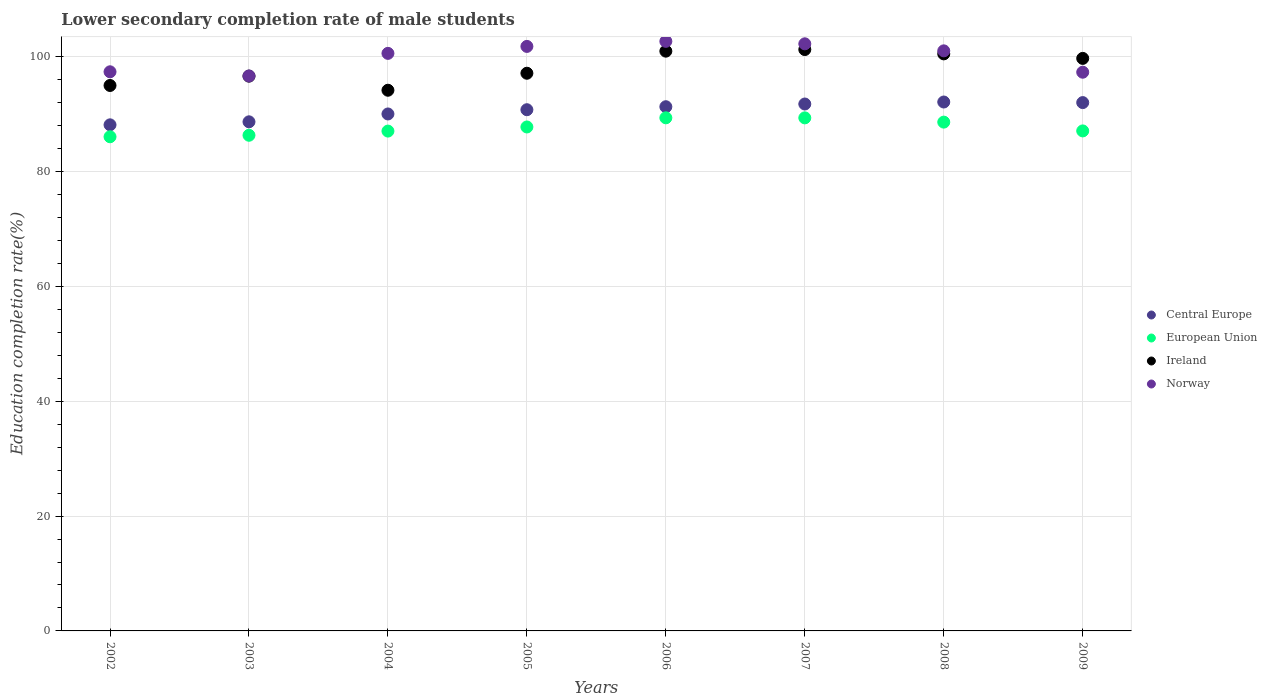How many different coloured dotlines are there?
Make the answer very short. 4. Is the number of dotlines equal to the number of legend labels?
Ensure brevity in your answer.  Yes. What is the lower secondary completion rate of male students in European Union in 2009?
Ensure brevity in your answer.  87.06. Across all years, what is the maximum lower secondary completion rate of male students in Norway?
Your answer should be very brief. 102.66. Across all years, what is the minimum lower secondary completion rate of male students in Ireland?
Make the answer very short. 94.14. What is the total lower secondary completion rate of male students in Ireland in the graph?
Provide a succinct answer. 785.17. What is the difference between the lower secondary completion rate of male students in Ireland in 2003 and that in 2008?
Keep it short and to the point. -3.88. What is the difference between the lower secondary completion rate of male students in European Union in 2003 and the lower secondary completion rate of male students in Central Europe in 2009?
Offer a very short reply. -5.69. What is the average lower secondary completion rate of male students in Norway per year?
Ensure brevity in your answer.  99.94. In the year 2003, what is the difference between the lower secondary completion rate of male students in Central Europe and lower secondary completion rate of male students in Norway?
Provide a succinct answer. -7.98. In how many years, is the lower secondary completion rate of male students in Norway greater than 8 %?
Keep it short and to the point. 8. What is the ratio of the lower secondary completion rate of male students in Norway in 2002 to that in 2007?
Offer a very short reply. 0.95. What is the difference between the highest and the second highest lower secondary completion rate of male students in Norway?
Provide a short and direct response. 0.43. What is the difference between the highest and the lowest lower secondary completion rate of male students in European Union?
Offer a terse response. 3.3. In how many years, is the lower secondary completion rate of male students in European Union greater than the average lower secondary completion rate of male students in European Union taken over all years?
Your response must be concise. 4. Is it the case that in every year, the sum of the lower secondary completion rate of male students in Norway and lower secondary completion rate of male students in Central Europe  is greater than the lower secondary completion rate of male students in Ireland?
Give a very brief answer. Yes. Does the lower secondary completion rate of male students in Ireland monotonically increase over the years?
Provide a short and direct response. No. Is the lower secondary completion rate of male students in Ireland strictly greater than the lower secondary completion rate of male students in Norway over the years?
Offer a very short reply. No. Is the lower secondary completion rate of male students in Ireland strictly less than the lower secondary completion rate of male students in Norway over the years?
Your answer should be very brief. No. How many dotlines are there?
Your answer should be very brief. 4. Does the graph contain grids?
Your response must be concise. Yes. How many legend labels are there?
Your answer should be very brief. 4. What is the title of the graph?
Offer a terse response. Lower secondary completion rate of male students. What is the label or title of the X-axis?
Make the answer very short. Years. What is the label or title of the Y-axis?
Make the answer very short. Education completion rate(%). What is the Education completion rate(%) in Central Europe in 2002?
Provide a succinct answer. 88.12. What is the Education completion rate(%) in European Union in 2002?
Give a very brief answer. 86.04. What is the Education completion rate(%) of Ireland in 2002?
Your answer should be very brief. 94.97. What is the Education completion rate(%) of Norway in 2002?
Offer a terse response. 97.36. What is the Education completion rate(%) of Central Europe in 2003?
Make the answer very short. 88.65. What is the Education completion rate(%) in European Union in 2003?
Offer a very short reply. 86.31. What is the Education completion rate(%) of Ireland in 2003?
Your response must be concise. 96.6. What is the Education completion rate(%) in Norway in 2003?
Give a very brief answer. 96.63. What is the Education completion rate(%) in Central Europe in 2004?
Your response must be concise. 90.01. What is the Education completion rate(%) in European Union in 2004?
Ensure brevity in your answer.  87.03. What is the Education completion rate(%) in Ireland in 2004?
Offer a terse response. 94.14. What is the Education completion rate(%) in Norway in 2004?
Your answer should be compact. 100.57. What is the Education completion rate(%) of Central Europe in 2005?
Your answer should be very brief. 90.75. What is the Education completion rate(%) of European Union in 2005?
Ensure brevity in your answer.  87.75. What is the Education completion rate(%) of Ireland in 2005?
Provide a succinct answer. 97.1. What is the Education completion rate(%) of Norway in 2005?
Keep it short and to the point. 101.78. What is the Education completion rate(%) of Central Europe in 2006?
Your answer should be compact. 91.27. What is the Education completion rate(%) of European Union in 2006?
Your response must be concise. 89.34. What is the Education completion rate(%) in Ireland in 2006?
Provide a succinct answer. 100.95. What is the Education completion rate(%) of Norway in 2006?
Ensure brevity in your answer.  102.66. What is the Education completion rate(%) of Central Europe in 2007?
Keep it short and to the point. 91.75. What is the Education completion rate(%) in European Union in 2007?
Your response must be concise. 89.34. What is the Education completion rate(%) in Ireland in 2007?
Ensure brevity in your answer.  101.23. What is the Education completion rate(%) in Norway in 2007?
Your response must be concise. 102.23. What is the Education completion rate(%) in Central Europe in 2008?
Provide a short and direct response. 92.1. What is the Education completion rate(%) in European Union in 2008?
Provide a short and direct response. 88.59. What is the Education completion rate(%) of Ireland in 2008?
Keep it short and to the point. 100.48. What is the Education completion rate(%) in Norway in 2008?
Your answer should be compact. 101. What is the Education completion rate(%) of Central Europe in 2009?
Your response must be concise. 91.99. What is the Education completion rate(%) in European Union in 2009?
Give a very brief answer. 87.06. What is the Education completion rate(%) of Ireland in 2009?
Ensure brevity in your answer.  99.69. What is the Education completion rate(%) of Norway in 2009?
Your answer should be compact. 97.28. Across all years, what is the maximum Education completion rate(%) in Central Europe?
Offer a very short reply. 92.1. Across all years, what is the maximum Education completion rate(%) in European Union?
Offer a terse response. 89.34. Across all years, what is the maximum Education completion rate(%) in Ireland?
Offer a terse response. 101.23. Across all years, what is the maximum Education completion rate(%) of Norway?
Ensure brevity in your answer.  102.66. Across all years, what is the minimum Education completion rate(%) in Central Europe?
Offer a terse response. 88.12. Across all years, what is the minimum Education completion rate(%) of European Union?
Give a very brief answer. 86.04. Across all years, what is the minimum Education completion rate(%) in Ireland?
Make the answer very short. 94.14. Across all years, what is the minimum Education completion rate(%) in Norway?
Offer a very short reply. 96.63. What is the total Education completion rate(%) of Central Europe in the graph?
Your answer should be compact. 724.64. What is the total Education completion rate(%) in European Union in the graph?
Offer a terse response. 701.47. What is the total Education completion rate(%) of Ireland in the graph?
Your answer should be very brief. 785.17. What is the total Education completion rate(%) of Norway in the graph?
Your answer should be very brief. 799.5. What is the difference between the Education completion rate(%) of Central Europe in 2002 and that in 2003?
Your response must be concise. -0.53. What is the difference between the Education completion rate(%) of European Union in 2002 and that in 2003?
Ensure brevity in your answer.  -0.26. What is the difference between the Education completion rate(%) of Ireland in 2002 and that in 2003?
Make the answer very short. -1.63. What is the difference between the Education completion rate(%) of Norway in 2002 and that in 2003?
Give a very brief answer. 0.73. What is the difference between the Education completion rate(%) in Central Europe in 2002 and that in 2004?
Offer a terse response. -1.89. What is the difference between the Education completion rate(%) in European Union in 2002 and that in 2004?
Your answer should be compact. -0.99. What is the difference between the Education completion rate(%) in Ireland in 2002 and that in 2004?
Ensure brevity in your answer.  0.83. What is the difference between the Education completion rate(%) in Norway in 2002 and that in 2004?
Offer a very short reply. -3.21. What is the difference between the Education completion rate(%) in Central Europe in 2002 and that in 2005?
Offer a very short reply. -2.63. What is the difference between the Education completion rate(%) of European Union in 2002 and that in 2005?
Keep it short and to the point. -1.7. What is the difference between the Education completion rate(%) of Ireland in 2002 and that in 2005?
Keep it short and to the point. -2.13. What is the difference between the Education completion rate(%) in Norway in 2002 and that in 2005?
Your response must be concise. -4.42. What is the difference between the Education completion rate(%) in Central Europe in 2002 and that in 2006?
Make the answer very short. -3.15. What is the difference between the Education completion rate(%) in European Union in 2002 and that in 2006?
Keep it short and to the point. -3.3. What is the difference between the Education completion rate(%) of Ireland in 2002 and that in 2006?
Offer a terse response. -5.98. What is the difference between the Education completion rate(%) in Norway in 2002 and that in 2006?
Make the answer very short. -5.3. What is the difference between the Education completion rate(%) of Central Europe in 2002 and that in 2007?
Your answer should be compact. -3.63. What is the difference between the Education completion rate(%) of European Union in 2002 and that in 2007?
Offer a terse response. -3.29. What is the difference between the Education completion rate(%) in Ireland in 2002 and that in 2007?
Ensure brevity in your answer.  -6.26. What is the difference between the Education completion rate(%) of Norway in 2002 and that in 2007?
Make the answer very short. -4.87. What is the difference between the Education completion rate(%) of Central Europe in 2002 and that in 2008?
Your response must be concise. -3.97. What is the difference between the Education completion rate(%) of European Union in 2002 and that in 2008?
Ensure brevity in your answer.  -2.55. What is the difference between the Education completion rate(%) of Ireland in 2002 and that in 2008?
Your response must be concise. -5.5. What is the difference between the Education completion rate(%) in Norway in 2002 and that in 2008?
Your response must be concise. -3.65. What is the difference between the Education completion rate(%) in Central Europe in 2002 and that in 2009?
Provide a short and direct response. -3.87. What is the difference between the Education completion rate(%) of European Union in 2002 and that in 2009?
Make the answer very short. -1.02. What is the difference between the Education completion rate(%) of Ireland in 2002 and that in 2009?
Keep it short and to the point. -4.72. What is the difference between the Education completion rate(%) in Norway in 2002 and that in 2009?
Offer a very short reply. 0.07. What is the difference between the Education completion rate(%) in Central Europe in 2003 and that in 2004?
Provide a succinct answer. -1.37. What is the difference between the Education completion rate(%) in European Union in 2003 and that in 2004?
Make the answer very short. -0.73. What is the difference between the Education completion rate(%) in Ireland in 2003 and that in 2004?
Provide a succinct answer. 2.46. What is the difference between the Education completion rate(%) in Norway in 2003 and that in 2004?
Your answer should be compact. -3.93. What is the difference between the Education completion rate(%) of Central Europe in 2003 and that in 2005?
Ensure brevity in your answer.  -2.11. What is the difference between the Education completion rate(%) of European Union in 2003 and that in 2005?
Your answer should be compact. -1.44. What is the difference between the Education completion rate(%) in Ireland in 2003 and that in 2005?
Offer a terse response. -0.5. What is the difference between the Education completion rate(%) of Norway in 2003 and that in 2005?
Give a very brief answer. -5.14. What is the difference between the Education completion rate(%) of Central Europe in 2003 and that in 2006?
Your answer should be very brief. -2.63. What is the difference between the Education completion rate(%) in European Union in 2003 and that in 2006?
Offer a very short reply. -3.04. What is the difference between the Education completion rate(%) in Ireland in 2003 and that in 2006?
Ensure brevity in your answer.  -4.35. What is the difference between the Education completion rate(%) of Norway in 2003 and that in 2006?
Make the answer very short. -6.03. What is the difference between the Education completion rate(%) in Central Europe in 2003 and that in 2007?
Provide a succinct answer. -3.1. What is the difference between the Education completion rate(%) in European Union in 2003 and that in 2007?
Give a very brief answer. -3.03. What is the difference between the Education completion rate(%) of Ireland in 2003 and that in 2007?
Offer a terse response. -4.63. What is the difference between the Education completion rate(%) of Norway in 2003 and that in 2007?
Provide a short and direct response. -5.6. What is the difference between the Education completion rate(%) in Central Europe in 2003 and that in 2008?
Offer a very short reply. -3.45. What is the difference between the Education completion rate(%) in European Union in 2003 and that in 2008?
Provide a succinct answer. -2.29. What is the difference between the Education completion rate(%) of Ireland in 2003 and that in 2008?
Offer a terse response. -3.88. What is the difference between the Education completion rate(%) in Norway in 2003 and that in 2008?
Your response must be concise. -4.37. What is the difference between the Education completion rate(%) in Central Europe in 2003 and that in 2009?
Give a very brief answer. -3.35. What is the difference between the Education completion rate(%) in European Union in 2003 and that in 2009?
Provide a succinct answer. -0.76. What is the difference between the Education completion rate(%) of Ireland in 2003 and that in 2009?
Provide a short and direct response. -3.09. What is the difference between the Education completion rate(%) in Norway in 2003 and that in 2009?
Offer a very short reply. -0.65. What is the difference between the Education completion rate(%) of Central Europe in 2004 and that in 2005?
Offer a very short reply. -0.74. What is the difference between the Education completion rate(%) in European Union in 2004 and that in 2005?
Keep it short and to the point. -0.72. What is the difference between the Education completion rate(%) in Ireland in 2004 and that in 2005?
Keep it short and to the point. -2.96. What is the difference between the Education completion rate(%) in Norway in 2004 and that in 2005?
Give a very brief answer. -1.21. What is the difference between the Education completion rate(%) in Central Europe in 2004 and that in 2006?
Ensure brevity in your answer.  -1.26. What is the difference between the Education completion rate(%) in European Union in 2004 and that in 2006?
Your response must be concise. -2.31. What is the difference between the Education completion rate(%) of Ireland in 2004 and that in 2006?
Your answer should be compact. -6.81. What is the difference between the Education completion rate(%) in Norway in 2004 and that in 2006?
Offer a very short reply. -2.09. What is the difference between the Education completion rate(%) in Central Europe in 2004 and that in 2007?
Provide a short and direct response. -1.73. What is the difference between the Education completion rate(%) in European Union in 2004 and that in 2007?
Offer a very short reply. -2.3. What is the difference between the Education completion rate(%) of Ireland in 2004 and that in 2007?
Your answer should be compact. -7.09. What is the difference between the Education completion rate(%) in Norway in 2004 and that in 2007?
Give a very brief answer. -1.66. What is the difference between the Education completion rate(%) in Central Europe in 2004 and that in 2008?
Provide a succinct answer. -2.08. What is the difference between the Education completion rate(%) in European Union in 2004 and that in 2008?
Ensure brevity in your answer.  -1.56. What is the difference between the Education completion rate(%) of Ireland in 2004 and that in 2008?
Your answer should be very brief. -6.33. What is the difference between the Education completion rate(%) of Norway in 2004 and that in 2008?
Your answer should be compact. -0.44. What is the difference between the Education completion rate(%) in Central Europe in 2004 and that in 2009?
Provide a succinct answer. -1.98. What is the difference between the Education completion rate(%) in European Union in 2004 and that in 2009?
Give a very brief answer. -0.03. What is the difference between the Education completion rate(%) in Ireland in 2004 and that in 2009?
Provide a short and direct response. -5.54. What is the difference between the Education completion rate(%) of Norway in 2004 and that in 2009?
Your response must be concise. 3.28. What is the difference between the Education completion rate(%) in Central Europe in 2005 and that in 2006?
Give a very brief answer. -0.52. What is the difference between the Education completion rate(%) in European Union in 2005 and that in 2006?
Make the answer very short. -1.59. What is the difference between the Education completion rate(%) in Ireland in 2005 and that in 2006?
Provide a succinct answer. -3.85. What is the difference between the Education completion rate(%) of Norway in 2005 and that in 2006?
Make the answer very short. -0.88. What is the difference between the Education completion rate(%) in Central Europe in 2005 and that in 2007?
Give a very brief answer. -0.99. What is the difference between the Education completion rate(%) of European Union in 2005 and that in 2007?
Provide a succinct answer. -1.59. What is the difference between the Education completion rate(%) of Ireland in 2005 and that in 2007?
Offer a terse response. -4.12. What is the difference between the Education completion rate(%) of Norway in 2005 and that in 2007?
Provide a short and direct response. -0.45. What is the difference between the Education completion rate(%) in Central Europe in 2005 and that in 2008?
Provide a succinct answer. -1.34. What is the difference between the Education completion rate(%) of European Union in 2005 and that in 2008?
Ensure brevity in your answer.  -0.84. What is the difference between the Education completion rate(%) in Ireland in 2005 and that in 2008?
Provide a short and direct response. -3.37. What is the difference between the Education completion rate(%) of Norway in 2005 and that in 2008?
Ensure brevity in your answer.  0.77. What is the difference between the Education completion rate(%) of Central Europe in 2005 and that in 2009?
Keep it short and to the point. -1.24. What is the difference between the Education completion rate(%) of European Union in 2005 and that in 2009?
Offer a very short reply. 0.69. What is the difference between the Education completion rate(%) in Ireland in 2005 and that in 2009?
Make the answer very short. -2.58. What is the difference between the Education completion rate(%) in Norway in 2005 and that in 2009?
Your answer should be very brief. 4.49. What is the difference between the Education completion rate(%) in Central Europe in 2006 and that in 2007?
Your response must be concise. -0.47. What is the difference between the Education completion rate(%) in European Union in 2006 and that in 2007?
Your response must be concise. 0.01. What is the difference between the Education completion rate(%) in Ireland in 2006 and that in 2007?
Keep it short and to the point. -0.28. What is the difference between the Education completion rate(%) in Norway in 2006 and that in 2007?
Provide a succinct answer. 0.43. What is the difference between the Education completion rate(%) of Central Europe in 2006 and that in 2008?
Give a very brief answer. -0.82. What is the difference between the Education completion rate(%) in European Union in 2006 and that in 2008?
Make the answer very short. 0.75. What is the difference between the Education completion rate(%) in Ireland in 2006 and that in 2008?
Keep it short and to the point. 0.47. What is the difference between the Education completion rate(%) of Norway in 2006 and that in 2008?
Provide a succinct answer. 1.65. What is the difference between the Education completion rate(%) in Central Europe in 2006 and that in 2009?
Offer a very short reply. -0.72. What is the difference between the Education completion rate(%) in European Union in 2006 and that in 2009?
Give a very brief answer. 2.28. What is the difference between the Education completion rate(%) in Ireland in 2006 and that in 2009?
Your response must be concise. 1.26. What is the difference between the Education completion rate(%) in Norway in 2006 and that in 2009?
Give a very brief answer. 5.38. What is the difference between the Education completion rate(%) in Central Europe in 2007 and that in 2008?
Provide a succinct answer. -0.35. What is the difference between the Education completion rate(%) of European Union in 2007 and that in 2008?
Offer a very short reply. 0.74. What is the difference between the Education completion rate(%) in Ireland in 2007 and that in 2008?
Give a very brief answer. 0.75. What is the difference between the Education completion rate(%) of Norway in 2007 and that in 2008?
Offer a very short reply. 1.22. What is the difference between the Education completion rate(%) in Central Europe in 2007 and that in 2009?
Ensure brevity in your answer.  -0.25. What is the difference between the Education completion rate(%) of European Union in 2007 and that in 2009?
Offer a very short reply. 2.27. What is the difference between the Education completion rate(%) of Ireland in 2007 and that in 2009?
Keep it short and to the point. 1.54. What is the difference between the Education completion rate(%) of Norway in 2007 and that in 2009?
Provide a succinct answer. 4.94. What is the difference between the Education completion rate(%) of Central Europe in 2008 and that in 2009?
Make the answer very short. 0.1. What is the difference between the Education completion rate(%) of European Union in 2008 and that in 2009?
Your answer should be compact. 1.53. What is the difference between the Education completion rate(%) of Ireland in 2008 and that in 2009?
Give a very brief answer. 0.79. What is the difference between the Education completion rate(%) of Norway in 2008 and that in 2009?
Offer a very short reply. 3.72. What is the difference between the Education completion rate(%) in Central Europe in 2002 and the Education completion rate(%) in European Union in 2003?
Your response must be concise. 1.82. What is the difference between the Education completion rate(%) in Central Europe in 2002 and the Education completion rate(%) in Ireland in 2003?
Provide a short and direct response. -8.48. What is the difference between the Education completion rate(%) in Central Europe in 2002 and the Education completion rate(%) in Norway in 2003?
Your response must be concise. -8.51. What is the difference between the Education completion rate(%) of European Union in 2002 and the Education completion rate(%) of Ireland in 2003?
Your response must be concise. -10.56. What is the difference between the Education completion rate(%) of European Union in 2002 and the Education completion rate(%) of Norway in 2003?
Keep it short and to the point. -10.59. What is the difference between the Education completion rate(%) of Ireland in 2002 and the Education completion rate(%) of Norway in 2003?
Offer a very short reply. -1.66. What is the difference between the Education completion rate(%) of Central Europe in 2002 and the Education completion rate(%) of European Union in 2004?
Keep it short and to the point. 1.09. What is the difference between the Education completion rate(%) in Central Europe in 2002 and the Education completion rate(%) in Ireland in 2004?
Ensure brevity in your answer.  -6.02. What is the difference between the Education completion rate(%) in Central Europe in 2002 and the Education completion rate(%) in Norway in 2004?
Your response must be concise. -12.44. What is the difference between the Education completion rate(%) of European Union in 2002 and the Education completion rate(%) of Ireland in 2004?
Your response must be concise. -8.1. What is the difference between the Education completion rate(%) of European Union in 2002 and the Education completion rate(%) of Norway in 2004?
Offer a very short reply. -14.52. What is the difference between the Education completion rate(%) of Ireland in 2002 and the Education completion rate(%) of Norway in 2004?
Provide a short and direct response. -5.59. What is the difference between the Education completion rate(%) in Central Europe in 2002 and the Education completion rate(%) in European Union in 2005?
Your answer should be very brief. 0.37. What is the difference between the Education completion rate(%) of Central Europe in 2002 and the Education completion rate(%) of Ireland in 2005?
Make the answer very short. -8.98. What is the difference between the Education completion rate(%) in Central Europe in 2002 and the Education completion rate(%) in Norway in 2005?
Provide a short and direct response. -13.66. What is the difference between the Education completion rate(%) of European Union in 2002 and the Education completion rate(%) of Ireland in 2005?
Give a very brief answer. -11.06. What is the difference between the Education completion rate(%) of European Union in 2002 and the Education completion rate(%) of Norway in 2005?
Your response must be concise. -15.73. What is the difference between the Education completion rate(%) of Ireland in 2002 and the Education completion rate(%) of Norway in 2005?
Provide a succinct answer. -6.8. What is the difference between the Education completion rate(%) of Central Europe in 2002 and the Education completion rate(%) of European Union in 2006?
Ensure brevity in your answer.  -1.22. What is the difference between the Education completion rate(%) of Central Europe in 2002 and the Education completion rate(%) of Ireland in 2006?
Provide a short and direct response. -12.83. What is the difference between the Education completion rate(%) in Central Europe in 2002 and the Education completion rate(%) in Norway in 2006?
Give a very brief answer. -14.54. What is the difference between the Education completion rate(%) of European Union in 2002 and the Education completion rate(%) of Ireland in 2006?
Make the answer very short. -14.9. What is the difference between the Education completion rate(%) of European Union in 2002 and the Education completion rate(%) of Norway in 2006?
Keep it short and to the point. -16.61. What is the difference between the Education completion rate(%) in Ireland in 2002 and the Education completion rate(%) in Norway in 2006?
Your answer should be very brief. -7.69. What is the difference between the Education completion rate(%) of Central Europe in 2002 and the Education completion rate(%) of European Union in 2007?
Provide a succinct answer. -1.21. What is the difference between the Education completion rate(%) of Central Europe in 2002 and the Education completion rate(%) of Ireland in 2007?
Your answer should be very brief. -13.11. What is the difference between the Education completion rate(%) in Central Europe in 2002 and the Education completion rate(%) in Norway in 2007?
Offer a very short reply. -14.11. What is the difference between the Education completion rate(%) of European Union in 2002 and the Education completion rate(%) of Ireland in 2007?
Provide a succinct answer. -15.18. What is the difference between the Education completion rate(%) of European Union in 2002 and the Education completion rate(%) of Norway in 2007?
Your answer should be very brief. -16.18. What is the difference between the Education completion rate(%) of Ireland in 2002 and the Education completion rate(%) of Norway in 2007?
Provide a succinct answer. -7.25. What is the difference between the Education completion rate(%) in Central Europe in 2002 and the Education completion rate(%) in European Union in 2008?
Keep it short and to the point. -0.47. What is the difference between the Education completion rate(%) of Central Europe in 2002 and the Education completion rate(%) of Ireland in 2008?
Your answer should be very brief. -12.36. What is the difference between the Education completion rate(%) of Central Europe in 2002 and the Education completion rate(%) of Norway in 2008?
Ensure brevity in your answer.  -12.88. What is the difference between the Education completion rate(%) of European Union in 2002 and the Education completion rate(%) of Ireland in 2008?
Make the answer very short. -14.43. What is the difference between the Education completion rate(%) in European Union in 2002 and the Education completion rate(%) in Norway in 2008?
Your response must be concise. -14.96. What is the difference between the Education completion rate(%) in Ireland in 2002 and the Education completion rate(%) in Norway in 2008?
Give a very brief answer. -6.03. What is the difference between the Education completion rate(%) in Central Europe in 2002 and the Education completion rate(%) in European Union in 2009?
Offer a very short reply. 1.06. What is the difference between the Education completion rate(%) of Central Europe in 2002 and the Education completion rate(%) of Ireland in 2009?
Provide a succinct answer. -11.57. What is the difference between the Education completion rate(%) in Central Europe in 2002 and the Education completion rate(%) in Norway in 2009?
Keep it short and to the point. -9.16. What is the difference between the Education completion rate(%) of European Union in 2002 and the Education completion rate(%) of Ireland in 2009?
Provide a succinct answer. -13.64. What is the difference between the Education completion rate(%) in European Union in 2002 and the Education completion rate(%) in Norway in 2009?
Offer a very short reply. -11.24. What is the difference between the Education completion rate(%) in Ireland in 2002 and the Education completion rate(%) in Norway in 2009?
Make the answer very short. -2.31. What is the difference between the Education completion rate(%) of Central Europe in 2003 and the Education completion rate(%) of European Union in 2004?
Offer a very short reply. 1.61. What is the difference between the Education completion rate(%) of Central Europe in 2003 and the Education completion rate(%) of Ireland in 2004?
Make the answer very short. -5.5. What is the difference between the Education completion rate(%) of Central Europe in 2003 and the Education completion rate(%) of Norway in 2004?
Ensure brevity in your answer.  -11.92. What is the difference between the Education completion rate(%) in European Union in 2003 and the Education completion rate(%) in Ireland in 2004?
Keep it short and to the point. -7.84. What is the difference between the Education completion rate(%) of European Union in 2003 and the Education completion rate(%) of Norway in 2004?
Your response must be concise. -14.26. What is the difference between the Education completion rate(%) in Ireland in 2003 and the Education completion rate(%) in Norway in 2004?
Provide a succinct answer. -3.96. What is the difference between the Education completion rate(%) in Central Europe in 2003 and the Education completion rate(%) in European Union in 2005?
Ensure brevity in your answer.  0.9. What is the difference between the Education completion rate(%) in Central Europe in 2003 and the Education completion rate(%) in Ireland in 2005?
Give a very brief answer. -8.46. What is the difference between the Education completion rate(%) of Central Europe in 2003 and the Education completion rate(%) of Norway in 2005?
Your answer should be compact. -13.13. What is the difference between the Education completion rate(%) of European Union in 2003 and the Education completion rate(%) of Ireland in 2005?
Ensure brevity in your answer.  -10.8. What is the difference between the Education completion rate(%) of European Union in 2003 and the Education completion rate(%) of Norway in 2005?
Ensure brevity in your answer.  -15.47. What is the difference between the Education completion rate(%) in Ireland in 2003 and the Education completion rate(%) in Norway in 2005?
Provide a short and direct response. -5.18. What is the difference between the Education completion rate(%) in Central Europe in 2003 and the Education completion rate(%) in European Union in 2006?
Provide a succinct answer. -0.7. What is the difference between the Education completion rate(%) in Central Europe in 2003 and the Education completion rate(%) in Ireland in 2006?
Provide a short and direct response. -12.3. What is the difference between the Education completion rate(%) of Central Europe in 2003 and the Education completion rate(%) of Norway in 2006?
Offer a very short reply. -14.01. What is the difference between the Education completion rate(%) in European Union in 2003 and the Education completion rate(%) in Ireland in 2006?
Offer a terse response. -14.64. What is the difference between the Education completion rate(%) of European Union in 2003 and the Education completion rate(%) of Norway in 2006?
Offer a terse response. -16.35. What is the difference between the Education completion rate(%) in Ireland in 2003 and the Education completion rate(%) in Norway in 2006?
Give a very brief answer. -6.06. What is the difference between the Education completion rate(%) of Central Europe in 2003 and the Education completion rate(%) of European Union in 2007?
Offer a terse response. -0.69. What is the difference between the Education completion rate(%) in Central Europe in 2003 and the Education completion rate(%) in Ireland in 2007?
Your answer should be very brief. -12.58. What is the difference between the Education completion rate(%) in Central Europe in 2003 and the Education completion rate(%) in Norway in 2007?
Provide a succinct answer. -13.58. What is the difference between the Education completion rate(%) of European Union in 2003 and the Education completion rate(%) of Ireland in 2007?
Give a very brief answer. -14.92. What is the difference between the Education completion rate(%) of European Union in 2003 and the Education completion rate(%) of Norway in 2007?
Offer a very short reply. -15.92. What is the difference between the Education completion rate(%) in Ireland in 2003 and the Education completion rate(%) in Norway in 2007?
Provide a short and direct response. -5.63. What is the difference between the Education completion rate(%) in Central Europe in 2003 and the Education completion rate(%) in European Union in 2008?
Offer a terse response. 0.05. What is the difference between the Education completion rate(%) in Central Europe in 2003 and the Education completion rate(%) in Ireland in 2008?
Your response must be concise. -11.83. What is the difference between the Education completion rate(%) in Central Europe in 2003 and the Education completion rate(%) in Norway in 2008?
Make the answer very short. -12.36. What is the difference between the Education completion rate(%) of European Union in 2003 and the Education completion rate(%) of Ireland in 2008?
Keep it short and to the point. -14.17. What is the difference between the Education completion rate(%) in European Union in 2003 and the Education completion rate(%) in Norway in 2008?
Your answer should be very brief. -14.7. What is the difference between the Education completion rate(%) of Ireland in 2003 and the Education completion rate(%) of Norway in 2008?
Offer a terse response. -4.4. What is the difference between the Education completion rate(%) in Central Europe in 2003 and the Education completion rate(%) in European Union in 2009?
Your response must be concise. 1.58. What is the difference between the Education completion rate(%) of Central Europe in 2003 and the Education completion rate(%) of Ireland in 2009?
Your answer should be compact. -11.04. What is the difference between the Education completion rate(%) in Central Europe in 2003 and the Education completion rate(%) in Norway in 2009?
Provide a short and direct response. -8.64. What is the difference between the Education completion rate(%) of European Union in 2003 and the Education completion rate(%) of Ireland in 2009?
Provide a short and direct response. -13.38. What is the difference between the Education completion rate(%) in European Union in 2003 and the Education completion rate(%) in Norway in 2009?
Ensure brevity in your answer.  -10.98. What is the difference between the Education completion rate(%) in Ireland in 2003 and the Education completion rate(%) in Norway in 2009?
Provide a succinct answer. -0.68. What is the difference between the Education completion rate(%) in Central Europe in 2004 and the Education completion rate(%) in European Union in 2005?
Make the answer very short. 2.26. What is the difference between the Education completion rate(%) of Central Europe in 2004 and the Education completion rate(%) of Ireland in 2005?
Provide a succinct answer. -7.09. What is the difference between the Education completion rate(%) in Central Europe in 2004 and the Education completion rate(%) in Norway in 2005?
Offer a terse response. -11.76. What is the difference between the Education completion rate(%) of European Union in 2004 and the Education completion rate(%) of Ireland in 2005?
Offer a terse response. -10.07. What is the difference between the Education completion rate(%) in European Union in 2004 and the Education completion rate(%) in Norway in 2005?
Keep it short and to the point. -14.74. What is the difference between the Education completion rate(%) in Ireland in 2004 and the Education completion rate(%) in Norway in 2005?
Offer a very short reply. -7.63. What is the difference between the Education completion rate(%) in Central Europe in 2004 and the Education completion rate(%) in European Union in 2006?
Ensure brevity in your answer.  0.67. What is the difference between the Education completion rate(%) in Central Europe in 2004 and the Education completion rate(%) in Ireland in 2006?
Keep it short and to the point. -10.94. What is the difference between the Education completion rate(%) in Central Europe in 2004 and the Education completion rate(%) in Norway in 2006?
Make the answer very short. -12.64. What is the difference between the Education completion rate(%) in European Union in 2004 and the Education completion rate(%) in Ireland in 2006?
Ensure brevity in your answer.  -13.92. What is the difference between the Education completion rate(%) of European Union in 2004 and the Education completion rate(%) of Norway in 2006?
Your response must be concise. -15.63. What is the difference between the Education completion rate(%) of Ireland in 2004 and the Education completion rate(%) of Norway in 2006?
Make the answer very short. -8.51. What is the difference between the Education completion rate(%) in Central Europe in 2004 and the Education completion rate(%) in European Union in 2007?
Keep it short and to the point. 0.68. What is the difference between the Education completion rate(%) in Central Europe in 2004 and the Education completion rate(%) in Ireland in 2007?
Make the answer very short. -11.21. What is the difference between the Education completion rate(%) of Central Europe in 2004 and the Education completion rate(%) of Norway in 2007?
Keep it short and to the point. -12.21. What is the difference between the Education completion rate(%) of European Union in 2004 and the Education completion rate(%) of Ireland in 2007?
Your answer should be compact. -14.2. What is the difference between the Education completion rate(%) of European Union in 2004 and the Education completion rate(%) of Norway in 2007?
Provide a succinct answer. -15.19. What is the difference between the Education completion rate(%) of Ireland in 2004 and the Education completion rate(%) of Norway in 2007?
Your answer should be compact. -8.08. What is the difference between the Education completion rate(%) in Central Europe in 2004 and the Education completion rate(%) in European Union in 2008?
Provide a short and direct response. 1.42. What is the difference between the Education completion rate(%) of Central Europe in 2004 and the Education completion rate(%) of Ireland in 2008?
Give a very brief answer. -10.46. What is the difference between the Education completion rate(%) of Central Europe in 2004 and the Education completion rate(%) of Norway in 2008?
Offer a very short reply. -10.99. What is the difference between the Education completion rate(%) in European Union in 2004 and the Education completion rate(%) in Ireland in 2008?
Your response must be concise. -13.44. What is the difference between the Education completion rate(%) of European Union in 2004 and the Education completion rate(%) of Norway in 2008?
Provide a succinct answer. -13.97. What is the difference between the Education completion rate(%) of Ireland in 2004 and the Education completion rate(%) of Norway in 2008?
Keep it short and to the point. -6.86. What is the difference between the Education completion rate(%) in Central Europe in 2004 and the Education completion rate(%) in European Union in 2009?
Ensure brevity in your answer.  2.95. What is the difference between the Education completion rate(%) in Central Europe in 2004 and the Education completion rate(%) in Ireland in 2009?
Make the answer very short. -9.67. What is the difference between the Education completion rate(%) in Central Europe in 2004 and the Education completion rate(%) in Norway in 2009?
Provide a short and direct response. -7.27. What is the difference between the Education completion rate(%) of European Union in 2004 and the Education completion rate(%) of Ireland in 2009?
Provide a succinct answer. -12.66. What is the difference between the Education completion rate(%) in European Union in 2004 and the Education completion rate(%) in Norway in 2009?
Offer a very short reply. -10.25. What is the difference between the Education completion rate(%) in Ireland in 2004 and the Education completion rate(%) in Norway in 2009?
Provide a short and direct response. -3.14. What is the difference between the Education completion rate(%) of Central Europe in 2005 and the Education completion rate(%) of European Union in 2006?
Provide a succinct answer. 1.41. What is the difference between the Education completion rate(%) of Central Europe in 2005 and the Education completion rate(%) of Ireland in 2006?
Offer a terse response. -10.2. What is the difference between the Education completion rate(%) of Central Europe in 2005 and the Education completion rate(%) of Norway in 2006?
Ensure brevity in your answer.  -11.91. What is the difference between the Education completion rate(%) in European Union in 2005 and the Education completion rate(%) in Ireland in 2006?
Keep it short and to the point. -13.2. What is the difference between the Education completion rate(%) of European Union in 2005 and the Education completion rate(%) of Norway in 2006?
Provide a short and direct response. -14.91. What is the difference between the Education completion rate(%) of Ireland in 2005 and the Education completion rate(%) of Norway in 2006?
Keep it short and to the point. -5.55. What is the difference between the Education completion rate(%) in Central Europe in 2005 and the Education completion rate(%) in European Union in 2007?
Provide a short and direct response. 1.42. What is the difference between the Education completion rate(%) in Central Europe in 2005 and the Education completion rate(%) in Ireland in 2007?
Offer a terse response. -10.48. What is the difference between the Education completion rate(%) in Central Europe in 2005 and the Education completion rate(%) in Norway in 2007?
Give a very brief answer. -11.47. What is the difference between the Education completion rate(%) in European Union in 2005 and the Education completion rate(%) in Ireland in 2007?
Offer a terse response. -13.48. What is the difference between the Education completion rate(%) of European Union in 2005 and the Education completion rate(%) of Norway in 2007?
Offer a very short reply. -14.48. What is the difference between the Education completion rate(%) of Ireland in 2005 and the Education completion rate(%) of Norway in 2007?
Provide a short and direct response. -5.12. What is the difference between the Education completion rate(%) of Central Europe in 2005 and the Education completion rate(%) of European Union in 2008?
Your answer should be very brief. 2.16. What is the difference between the Education completion rate(%) of Central Europe in 2005 and the Education completion rate(%) of Ireland in 2008?
Make the answer very short. -9.72. What is the difference between the Education completion rate(%) in Central Europe in 2005 and the Education completion rate(%) in Norway in 2008?
Ensure brevity in your answer.  -10.25. What is the difference between the Education completion rate(%) in European Union in 2005 and the Education completion rate(%) in Ireland in 2008?
Your response must be concise. -12.73. What is the difference between the Education completion rate(%) of European Union in 2005 and the Education completion rate(%) of Norway in 2008?
Your answer should be very brief. -13.25. What is the difference between the Education completion rate(%) of Ireland in 2005 and the Education completion rate(%) of Norway in 2008?
Make the answer very short. -3.9. What is the difference between the Education completion rate(%) in Central Europe in 2005 and the Education completion rate(%) in European Union in 2009?
Offer a very short reply. 3.69. What is the difference between the Education completion rate(%) in Central Europe in 2005 and the Education completion rate(%) in Ireland in 2009?
Your answer should be very brief. -8.94. What is the difference between the Education completion rate(%) in Central Europe in 2005 and the Education completion rate(%) in Norway in 2009?
Make the answer very short. -6.53. What is the difference between the Education completion rate(%) in European Union in 2005 and the Education completion rate(%) in Ireland in 2009?
Your answer should be very brief. -11.94. What is the difference between the Education completion rate(%) in European Union in 2005 and the Education completion rate(%) in Norway in 2009?
Offer a very short reply. -9.53. What is the difference between the Education completion rate(%) of Ireland in 2005 and the Education completion rate(%) of Norway in 2009?
Your answer should be compact. -0.18. What is the difference between the Education completion rate(%) of Central Europe in 2006 and the Education completion rate(%) of European Union in 2007?
Your answer should be very brief. 1.94. What is the difference between the Education completion rate(%) of Central Europe in 2006 and the Education completion rate(%) of Ireland in 2007?
Provide a succinct answer. -9.95. What is the difference between the Education completion rate(%) of Central Europe in 2006 and the Education completion rate(%) of Norway in 2007?
Ensure brevity in your answer.  -10.95. What is the difference between the Education completion rate(%) in European Union in 2006 and the Education completion rate(%) in Ireland in 2007?
Provide a short and direct response. -11.89. What is the difference between the Education completion rate(%) in European Union in 2006 and the Education completion rate(%) in Norway in 2007?
Provide a succinct answer. -12.88. What is the difference between the Education completion rate(%) of Ireland in 2006 and the Education completion rate(%) of Norway in 2007?
Your answer should be very brief. -1.28. What is the difference between the Education completion rate(%) of Central Europe in 2006 and the Education completion rate(%) of European Union in 2008?
Give a very brief answer. 2.68. What is the difference between the Education completion rate(%) in Central Europe in 2006 and the Education completion rate(%) in Ireland in 2008?
Your response must be concise. -9.2. What is the difference between the Education completion rate(%) of Central Europe in 2006 and the Education completion rate(%) of Norway in 2008?
Make the answer very short. -9.73. What is the difference between the Education completion rate(%) in European Union in 2006 and the Education completion rate(%) in Ireland in 2008?
Make the answer very short. -11.13. What is the difference between the Education completion rate(%) of European Union in 2006 and the Education completion rate(%) of Norway in 2008?
Your response must be concise. -11.66. What is the difference between the Education completion rate(%) of Ireland in 2006 and the Education completion rate(%) of Norway in 2008?
Ensure brevity in your answer.  -0.05. What is the difference between the Education completion rate(%) in Central Europe in 2006 and the Education completion rate(%) in European Union in 2009?
Your answer should be compact. 4.21. What is the difference between the Education completion rate(%) in Central Europe in 2006 and the Education completion rate(%) in Ireland in 2009?
Give a very brief answer. -8.41. What is the difference between the Education completion rate(%) in Central Europe in 2006 and the Education completion rate(%) in Norway in 2009?
Offer a terse response. -6.01. What is the difference between the Education completion rate(%) of European Union in 2006 and the Education completion rate(%) of Ireland in 2009?
Provide a short and direct response. -10.35. What is the difference between the Education completion rate(%) in European Union in 2006 and the Education completion rate(%) in Norway in 2009?
Make the answer very short. -7.94. What is the difference between the Education completion rate(%) in Ireland in 2006 and the Education completion rate(%) in Norway in 2009?
Your answer should be very brief. 3.67. What is the difference between the Education completion rate(%) of Central Europe in 2007 and the Education completion rate(%) of European Union in 2008?
Your answer should be very brief. 3.15. What is the difference between the Education completion rate(%) in Central Europe in 2007 and the Education completion rate(%) in Ireland in 2008?
Ensure brevity in your answer.  -8.73. What is the difference between the Education completion rate(%) of Central Europe in 2007 and the Education completion rate(%) of Norway in 2008?
Keep it short and to the point. -9.26. What is the difference between the Education completion rate(%) of European Union in 2007 and the Education completion rate(%) of Ireland in 2008?
Keep it short and to the point. -11.14. What is the difference between the Education completion rate(%) of European Union in 2007 and the Education completion rate(%) of Norway in 2008?
Offer a very short reply. -11.67. What is the difference between the Education completion rate(%) of Ireland in 2007 and the Education completion rate(%) of Norway in 2008?
Keep it short and to the point. 0.23. What is the difference between the Education completion rate(%) of Central Europe in 2007 and the Education completion rate(%) of European Union in 2009?
Provide a succinct answer. 4.68. What is the difference between the Education completion rate(%) of Central Europe in 2007 and the Education completion rate(%) of Ireland in 2009?
Provide a succinct answer. -7.94. What is the difference between the Education completion rate(%) in Central Europe in 2007 and the Education completion rate(%) in Norway in 2009?
Offer a terse response. -5.54. What is the difference between the Education completion rate(%) of European Union in 2007 and the Education completion rate(%) of Ireland in 2009?
Offer a very short reply. -10.35. What is the difference between the Education completion rate(%) of European Union in 2007 and the Education completion rate(%) of Norway in 2009?
Offer a terse response. -7.95. What is the difference between the Education completion rate(%) of Ireland in 2007 and the Education completion rate(%) of Norway in 2009?
Your answer should be compact. 3.95. What is the difference between the Education completion rate(%) in Central Europe in 2008 and the Education completion rate(%) in European Union in 2009?
Ensure brevity in your answer.  5.03. What is the difference between the Education completion rate(%) of Central Europe in 2008 and the Education completion rate(%) of Ireland in 2009?
Offer a terse response. -7.59. What is the difference between the Education completion rate(%) in Central Europe in 2008 and the Education completion rate(%) in Norway in 2009?
Ensure brevity in your answer.  -5.19. What is the difference between the Education completion rate(%) of European Union in 2008 and the Education completion rate(%) of Ireland in 2009?
Keep it short and to the point. -11.1. What is the difference between the Education completion rate(%) of European Union in 2008 and the Education completion rate(%) of Norway in 2009?
Your answer should be compact. -8.69. What is the difference between the Education completion rate(%) of Ireland in 2008 and the Education completion rate(%) of Norway in 2009?
Ensure brevity in your answer.  3.19. What is the average Education completion rate(%) of Central Europe per year?
Keep it short and to the point. 90.58. What is the average Education completion rate(%) in European Union per year?
Provide a short and direct response. 87.68. What is the average Education completion rate(%) of Ireland per year?
Provide a short and direct response. 98.15. What is the average Education completion rate(%) of Norway per year?
Provide a short and direct response. 99.94. In the year 2002, what is the difference between the Education completion rate(%) in Central Europe and Education completion rate(%) in European Union?
Keep it short and to the point. 2.08. In the year 2002, what is the difference between the Education completion rate(%) of Central Europe and Education completion rate(%) of Ireland?
Your answer should be compact. -6.85. In the year 2002, what is the difference between the Education completion rate(%) in Central Europe and Education completion rate(%) in Norway?
Keep it short and to the point. -9.24. In the year 2002, what is the difference between the Education completion rate(%) of European Union and Education completion rate(%) of Ireland?
Give a very brief answer. -8.93. In the year 2002, what is the difference between the Education completion rate(%) in European Union and Education completion rate(%) in Norway?
Ensure brevity in your answer.  -11.31. In the year 2002, what is the difference between the Education completion rate(%) in Ireland and Education completion rate(%) in Norway?
Offer a very short reply. -2.38. In the year 2003, what is the difference between the Education completion rate(%) of Central Europe and Education completion rate(%) of European Union?
Provide a succinct answer. 2.34. In the year 2003, what is the difference between the Education completion rate(%) in Central Europe and Education completion rate(%) in Ireland?
Give a very brief answer. -7.95. In the year 2003, what is the difference between the Education completion rate(%) of Central Europe and Education completion rate(%) of Norway?
Provide a succinct answer. -7.98. In the year 2003, what is the difference between the Education completion rate(%) of European Union and Education completion rate(%) of Ireland?
Provide a succinct answer. -10.3. In the year 2003, what is the difference between the Education completion rate(%) in European Union and Education completion rate(%) in Norway?
Provide a succinct answer. -10.33. In the year 2003, what is the difference between the Education completion rate(%) of Ireland and Education completion rate(%) of Norway?
Your answer should be very brief. -0.03. In the year 2004, what is the difference between the Education completion rate(%) in Central Europe and Education completion rate(%) in European Union?
Offer a terse response. 2.98. In the year 2004, what is the difference between the Education completion rate(%) in Central Europe and Education completion rate(%) in Ireland?
Offer a very short reply. -4.13. In the year 2004, what is the difference between the Education completion rate(%) of Central Europe and Education completion rate(%) of Norway?
Provide a short and direct response. -10.55. In the year 2004, what is the difference between the Education completion rate(%) in European Union and Education completion rate(%) in Ireland?
Offer a terse response. -7.11. In the year 2004, what is the difference between the Education completion rate(%) in European Union and Education completion rate(%) in Norway?
Offer a terse response. -13.53. In the year 2004, what is the difference between the Education completion rate(%) of Ireland and Education completion rate(%) of Norway?
Keep it short and to the point. -6.42. In the year 2005, what is the difference between the Education completion rate(%) of Central Europe and Education completion rate(%) of European Union?
Your answer should be very brief. 3. In the year 2005, what is the difference between the Education completion rate(%) of Central Europe and Education completion rate(%) of Ireland?
Give a very brief answer. -6.35. In the year 2005, what is the difference between the Education completion rate(%) of Central Europe and Education completion rate(%) of Norway?
Your answer should be very brief. -11.02. In the year 2005, what is the difference between the Education completion rate(%) in European Union and Education completion rate(%) in Ireland?
Your answer should be compact. -9.36. In the year 2005, what is the difference between the Education completion rate(%) in European Union and Education completion rate(%) in Norway?
Provide a succinct answer. -14.03. In the year 2005, what is the difference between the Education completion rate(%) of Ireland and Education completion rate(%) of Norway?
Provide a short and direct response. -4.67. In the year 2006, what is the difference between the Education completion rate(%) in Central Europe and Education completion rate(%) in European Union?
Keep it short and to the point. 1.93. In the year 2006, what is the difference between the Education completion rate(%) of Central Europe and Education completion rate(%) of Ireland?
Keep it short and to the point. -9.68. In the year 2006, what is the difference between the Education completion rate(%) of Central Europe and Education completion rate(%) of Norway?
Give a very brief answer. -11.38. In the year 2006, what is the difference between the Education completion rate(%) of European Union and Education completion rate(%) of Ireland?
Provide a succinct answer. -11.61. In the year 2006, what is the difference between the Education completion rate(%) in European Union and Education completion rate(%) in Norway?
Offer a very short reply. -13.32. In the year 2006, what is the difference between the Education completion rate(%) in Ireland and Education completion rate(%) in Norway?
Offer a terse response. -1.71. In the year 2007, what is the difference between the Education completion rate(%) of Central Europe and Education completion rate(%) of European Union?
Provide a short and direct response. 2.41. In the year 2007, what is the difference between the Education completion rate(%) of Central Europe and Education completion rate(%) of Ireland?
Make the answer very short. -9.48. In the year 2007, what is the difference between the Education completion rate(%) of Central Europe and Education completion rate(%) of Norway?
Offer a terse response. -10.48. In the year 2007, what is the difference between the Education completion rate(%) in European Union and Education completion rate(%) in Ireland?
Provide a short and direct response. -11.89. In the year 2007, what is the difference between the Education completion rate(%) of European Union and Education completion rate(%) of Norway?
Your answer should be very brief. -12.89. In the year 2007, what is the difference between the Education completion rate(%) of Ireland and Education completion rate(%) of Norway?
Give a very brief answer. -1. In the year 2008, what is the difference between the Education completion rate(%) in Central Europe and Education completion rate(%) in European Union?
Make the answer very short. 3.5. In the year 2008, what is the difference between the Education completion rate(%) in Central Europe and Education completion rate(%) in Ireland?
Your response must be concise. -8.38. In the year 2008, what is the difference between the Education completion rate(%) of Central Europe and Education completion rate(%) of Norway?
Keep it short and to the point. -8.91. In the year 2008, what is the difference between the Education completion rate(%) of European Union and Education completion rate(%) of Ireland?
Ensure brevity in your answer.  -11.88. In the year 2008, what is the difference between the Education completion rate(%) in European Union and Education completion rate(%) in Norway?
Ensure brevity in your answer.  -12.41. In the year 2008, what is the difference between the Education completion rate(%) of Ireland and Education completion rate(%) of Norway?
Your response must be concise. -0.53. In the year 2009, what is the difference between the Education completion rate(%) of Central Europe and Education completion rate(%) of European Union?
Provide a succinct answer. 4.93. In the year 2009, what is the difference between the Education completion rate(%) of Central Europe and Education completion rate(%) of Ireland?
Make the answer very short. -7.7. In the year 2009, what is the difference between the Education completion rate(%) in Central Europe and Education completion rate(%) in Norway?
Make the answer very short. -5.29. In the year 2009, what is the difference between the Education completion rate(%) in European Union and Education completion rate(%) in Ireland?
Provide a short and direct response. -12.63. In the year 2009, what is the difference between the Education completion rate(%) of European Union and Education completion rate(%) of Norway?
Your response must be concise. -10.22. In the year 2009, what is the difference between the Education completion rate(%) in Ireland and Education completion rate(%) in Norway?
Offer a very short reply. 2.41. What is the ratio of the Education completion rate(%) in Central Europe in 2002 to that in 2003?
Provide a short and direct response. 0.99. What is the ratio of the Education completion rate(%) in European Union in 2002 to that in 2003?
Give a very brief answer. 1. What is the ratio of the Education completion rate(%) in Ireland in 2002 to that in 2003?
Offer a terse response. 0.98. What is the ratio of the Education completion rate(%) in Norway in 2002 to that in 2003?
Your answer should be very brief. 1.01. What is the ratio of the Education completion rate(%) in Central Europe in 2002 to that in 2004?
Make the answer very short. 0.98. What is the ratio of the Education completion rate(%) in Ireland in 2002 to that in 2004?
Provide a succinct answer. 1.01. What is the ratio of the Education completion rate(%) in Norway in 2002 to that in 2004?
Make the answer very short. 0.97. What is the ratio of the Education completion rate(%) in European Union in 2002 to that in 2005?
Make the answer very short. 0.98. What is the ratio of the Education completion rate(%) of Norway in 2002 to that in 2005?
Provide a succinct answer. 0.96. What is the ratio of the Education completion rate(%) in Central Europe in 2002 to that in 2006?
Provide a succinct answer. 0.97. What is the ratio of the Education completion rate(%) of European Union in 2002 to that in 2006?
Your answer should be very brief. 0.96. What is the ratio of the Education completion rate(%) of Ireland in 2002 to that in 2006?
Your answer should be very brief. 0.94. What is the ratio of the Education completion rate(%) of Norway in 2002 to that in 2006?
Your response must be concise. 0.95. What is the ratio of the Education completion rate(%) of Central Europe in 2002 to that in 2007?
Your answer should be compact. 0.96. What is the ratio of the Education completion rate(%) in European Union in 2002 to that in 2007?
Make the answer very short. 0.96. What is the ratio of the Education completion rate(%) of Ireland in 2002 to that in 2007?
Provide a succinct answer. 0.94. What is the ratio of the Education completion rate(%) in Central Europe in 2002 to that in 2008?
Keep it short and to the point. 0.96. What is the ratio of the Education completion rate(%) of European Union in 2002 to that in 2008?
Ensure brevity in your answer.  0.97. What is the ratio of the Education completion rate(%) in Ireland in 2002 to that in 2008?
Your response must be concise. 0.95. What is the ratio of the Education completion rate(%) of Norway in 2002 to that in 2008?
Your response must be concise. 0.96. What is the ratio of the Education completion rate(%) in Central Europe in 2002 to that in 2009?
Your answer should be very brief. 0.96. What is the ratio of the Education completion rate(%) of European Union in 2002 to that in 2009?
Offer a terse response. 0.99. What is the ratio of the Education completion rate(%) in Ireland in 2002 to that in 2009?
Your answer should be very brief. 0.95. What is the ratio of the Education completion rate(%) in Norway in 2002 to that in 2009?
Provide a short and direct response. 1. What is the ratio of the Education completion rate(%) of Central Europe in 2003 to that in 2004?
Your response must be concise. 0.98. What is the ratio of the Education completion rate(%) of Ireland in 2003 to that in 2004?
Offer a terse response. 1.03. What is the ratio of the Education completion rate(%) of Norway in 2003 to that in 2004?
Your response must be concise. 0.96. What is the ratio of the Education completion rate(%) of Central Europe in 2003 to that in 2005?
Your response must be concise. 0.98. What is the ratio of the Education completion rate(%) of European Union in 2003 to that in 2005?
Your response must be concise. 0.98. What is the ratio of the Education completion rate(%) of Ireland in 2003 to that in 2005?
Your response must be concise. 0.99. What is the ratio of the Education completion rate(%) of Norway in 2003 to that in 2005?
Make the answer very short. 0.95. What is the ratio of the Education completion rate(%) of Central Europe in 2003 to that in 2006?
Keep it short and to the point. 0.97. What is the ratio of the Education completion rate(%) of Ireland in 2003 to that in 2006?
Your answer should be very brief. 0.96. What is the ratio of the Education completion rate(%) of Norway in 2003 to that in 2006?
Your answer should be compact. 0.94. What is the ratio of the Education completion rate(%) in Central Europe in 2003 to that in 2007?
Your answer should be very brief. 0.97. What is the ratio of the Education completion rate(%) in European Union in 2003 to that in 2007?
Make the answer very short. 0.97. What is the ratio of the Education completion rate(%) of Ireland in 2003 to that in 2007?
Your answer should be compact. 0.95. What is the ratio of the Education completion rate(%) in Norway in 2003 to that in 2007?
Make the answer very short. 0.95. What is the ratio of the Education completion rate(%) in Central Europe in 2003 to that in 2008?
Make the answer very short. 0.96. What is the ratio of the Education completion rate(%) of European Union in 2003 to that in 2008?
Ensure brevity in your answer.  0.97. What is the ratio of the Education completion rate(%) of Ireland in 2003 to that in 2008?
Offer a terse response. 0.96. What is the ratio of the Education completion rate(%) in Norway in 2003 to that in 2008?
Your answer should be very brief. 0.96. What is the ratio of the Education completion rate(%) in Central Europe in 2003 to that in 2009?
Provide a succinct answer. 0.96. What is the ratio of the Education completion rate(%) in Ireland in 2003 to that in 2009?
Offer a terse response. 0.97. What is the ratio of the Education completion rate(%) in Norway in 2003 to that in 2009?
Keep it short and to the point. 0.99. What is the ratio of the Education completion rate(%) in European Union in 2004 to that in 2005?
Make the answer very short. 0.99. What is the ratio of the Education completion rate(%) in Ireland in 2004 to that in 2005?
Offer a terse response. 0.97. What is the ratio of the Education completion rate(%) in Norway in 2004 to that in 2005?
Offer a terse response. 0.99. What is the ratio of the Education completion rate(%) in Central Europe in 2004 to that in 2006?
Provide a short and direct response. 0.99. What is the ratio of the Education completion rate(%) in European Union in 2004 to that in 2006?
Ensure brevity in your answer.  0.97. What is the ratio of the Education completion rate(%) in Ireland in 2004 to that in 2006?
Offer a very short reply. 0.93. What is the ratio of the Education completion rate(%) of Norway in 2004 to that in 2006?
Provide a succinct answer. 0.98. What is the ratio of the Education completion rate(%) in Central Europe in 2004 to that in 2007?
Keep it short and to the point. 0.98. What is the ratio of the Education completion rate(%) in European Union in 2004 to that in 2007?
Give a very brief answer. 0.97. What is the ratio of the Education completion rate(%) in Norway in 2004 to that in 2007?
Give a very brief answer. 0.98. What is the ratio of the Education completion rate(%) in Central Europe in 2004 to that in 2008?
Ensure brevity in your answer.  0.98. What is the ratio of the Education completion rate(%) in European Union in 2004 to that in 2008?
Make the answer very short. 0.98. What is the ratio of the Education completion rate(%) in Ireland in 2004 to that in 2008?
Provide a succinct answer. 0.94. What is the ratio of the Education completion rate(%) of Norway in 2004 to that in 2008?
Offer a terse response. 1. What is the ratio of the Education completion rate(%) in Central Europe in 2004 to that in 2009?
Your answer should be very brief. 0.98. What is the ratio of the Education completion rate(%) of European Union in 2004 to that in 2009?
Provide a short and direct response. 1. What is the ratio of the Education completion rate(%) in Ireland in 2004 to that in 2009?
Offer a very short reply. 0.94. What is the ratio of the Education completion rate(%) in Norway in 2004 to that in 2009?
Keep it short and to the point. 1.03. What is the ratio of the Education completion rate(%) in European Union in 2005 to that in 2006?
Ensure brevity in your answer.  0.98. What is the ratio of the Education completion rate(%) in Ireland in 2005 to that in 2006?
Offer a terse response. 0.96. What is the ratio of the Education completion rate(%) of Norway in 2005 to that in 2006?
Ensure brevity in your answer.  0.99. What is the ratio of the Education completion rate(%) in Central Europe in 2005 to that in 2007?
Your response must be concise. 0.99. What is the ratio of the Education completion rate(%) of European Union in 2005 to that in 2007?
Give a very brief answer. 0.98. What is the ratio of the Education completion rate(%) of Ireland in 2005 to that in 2007?
Make the answer very short. 0.96. What is the ratio of the Education completion rate(%) of Central Europe in 2005 to that in 2008?
Provide a short and direct response. 0.99. What is the ratio of the Education completion rate(%) of European Union in 2005 to that in 2008?
Ensure brevity in your answer.  0.99. What is the ratio of the Education completion rate(%) in Ireland in 2005 to that in 2008?
Offer a very short reply. 0.97. What is the ratio of the Education completion rate(%) in Norway in 2005 to that in 2008?
Offer a very short reply. 1.01. What is the ratio of the Education completion rate(%) of Central Europe in 2005 to that in 2009?
Ensure brevity in your answer.  0.99. What is the ratio of the Education completion rate(%) of European Union in 2005 to that in 2009?
Give a very brief answer. 1.01. What is the ratio of the Education completion rate(%) of Ireland in 2005 to that in 2009?
Provide a succinct answer. 0.97. What is the ratio of the Education completion rate(%) of Norway in 2005 to that in 2009?
Your answer should be very brief. 1.05. What is the ratio of the Education completion rate(%) in Central Europe in 2006 to that in 2007?
Ensure brevity in your answer.  0.99. What is the ratio of the Education completion rate(%) of Ireland in 2006 to that in 2007?
Give a very brief answer. 1. What is the ratio of the Education completion rate(%) in European Union in 2006 to that in 2008?
Offer a very short reply. 1.01. What is the ratio of the Education completion rate(%) of Norway in 2006 to that in 2008?
Your response must be concise. 1.02. What is the ratio of the Education completion rate(%) of European Union in 2006 to that in 2009?
Make the answer very short. 1.03. What is the ratio of the Education completion rate(%) in Ireland in 2006 to that in 2009?
Provide a short and direct response. 1.01. What is the ratio of the Education completion rate(%) of Norway in 2006 to that in 2009?
Ensure brevity in your answer.  1.06. What is the ratio of the Education completion rate(%) of Central Europe in 2007 to that in 2008?
Make the answer very short. 1. What is the ratio of the Education completion rate(%) in European Union in 2007 to that in 2008?
Offer a very short reply. 1.01. What is the ratio of the Education completion rate(%) in Ireland in 2007 to that in 2008?
Your response must be concise. 1.01. What is the ratio of the Education completion rate(%) of Norway in 2007 to that in 2008?
Make the answer very short. 1.01. What is the ratio of the Education completion rate(%) of Central Europe in 2007 to that in 2009?
Ensure brevity in your answer.  1. What is the ratio of the Education completion rate(%) of European Union in 2007 to that in 2009?
Offer a very short reply. 1.03. What is the ratio of the Education completion rate(%) in Ireland in 2007 to that in 2009?
Keep it short and to the point. 1.02. What is the ratio of the Education completion rate(%) in Norway in 2007 to that in 2009?
Make the answer very short. 1.05. What is the ratio of the Education completion rate(%) of European Union in 2008 to that in 2009?
Offer a terse response. 1.02. What is the ratio of the Education completion rate(%) of Ireland in 2008 to that in 2009?
Give a very brief answer. 1.01. What is the ratio of the Education completion rate(%) in Norway in 2008 to that in 2009?
Make the answer very short. 1.04. What is the difference between the highest and the second highest Education completion rate(%) of Central Europe?
Offer a very short reply. 0.1. What is the difference between the highest and the second highest Education completion rate(%) in European Union?
Provide a succinct answer. 0.01. What is the difference between the highest and the second highest Education completion rate(%) of Ireland?
Make the answer very short. 0.28. What is the difference between the highest and the second highest Education completion rate(%) of Norway?
Keep it short and to the point. 0.43. What is the difference between the highest and the lowest Education completion rate(%) in Central Europe?
Offer a very short reply. 3.97. What is the difference between the highest and the lowest Education completion rate(%) in European Union?
Your answer should be compact. 3.3. What is the difference between the highest and the lowest Education completion rate(%) in Ireland?
Keep it short and to the point. 7.09. What is the difference between the highest and the lowest Education completion rate(%) of Norway?
Give a very brief answer. 6.03. 